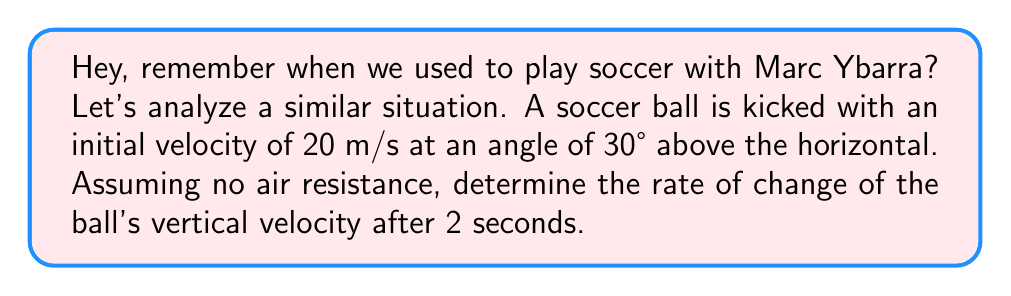Give your solution to this math problem. Let's approach this step-by-step:

1) First, we need to recall the equations of motion for projectile motion:

   Horizontal velocity: $v_x = v_0 \cos(\theta)$
   Vertical velocity: $v_y = v_0 \sin(\theta) - gt$

   Where $v_0$ is the initial velocity, $\theta$ is the angle, $g$ is the acceleration due to gravity (9.8 m/s²), and $t$ is time.

2) We're interested in the vertical velocity, so we'll focus on $v_y$.

3) Let's plug in our known values:
   $v_0 = 20$ m/s
   $\theta = 30°$
   $g = 9.8$ m/s²

4) Now, let's write out the equation for $v_y$:

   $v_y = 20 \sin(30°) - 9.8t$

5) Simplify:
   $v_y = 10 - 9.8t$

6) To find the rate of change of $v_y$, we need to differentiate with respect to time:

   $$\frac{d}{dt}v_y = \frac{d}{dt}(10 - 9.8t) = -9.8$$

7) This result, -9.8 m/s², is constant and doesn't depend on time. It's equal to -g, which makes sense as the acceleration due to gravity is constant (ignoring air resistance).

Therefore, the rate of change of the ball's vertical velocity after 2 seconds (or at any time) is -9.8 m/s².
Answer: -9.8 m/s² 